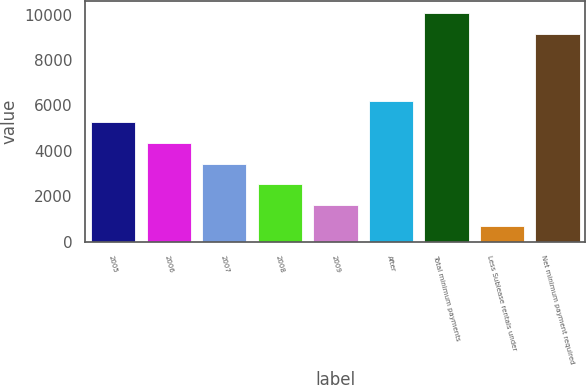Convert chart to OTSL. <chart><loc_0><loc_0><loc_500><loc_500><bar_chart><fcel>2005<fcel>2006<fcel>2007<fcel>2008<fcel>2009<fcel>After<fcel>Total minimum payments<fcel>Less Sublease rentals under<fcel>Net minimum payment required<nl><fcel>5271<fcel>4354.6<fcel>3438.2<fcel>2521.8<fcel>1605.4<fcel>6187.4<fcel>10080.4<fcel>689<fcel>9164<nl></chart> 